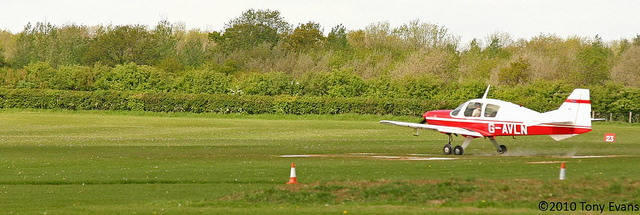Identify and read out the text in this image. Tony Evans 2010 c G AVLN 23 